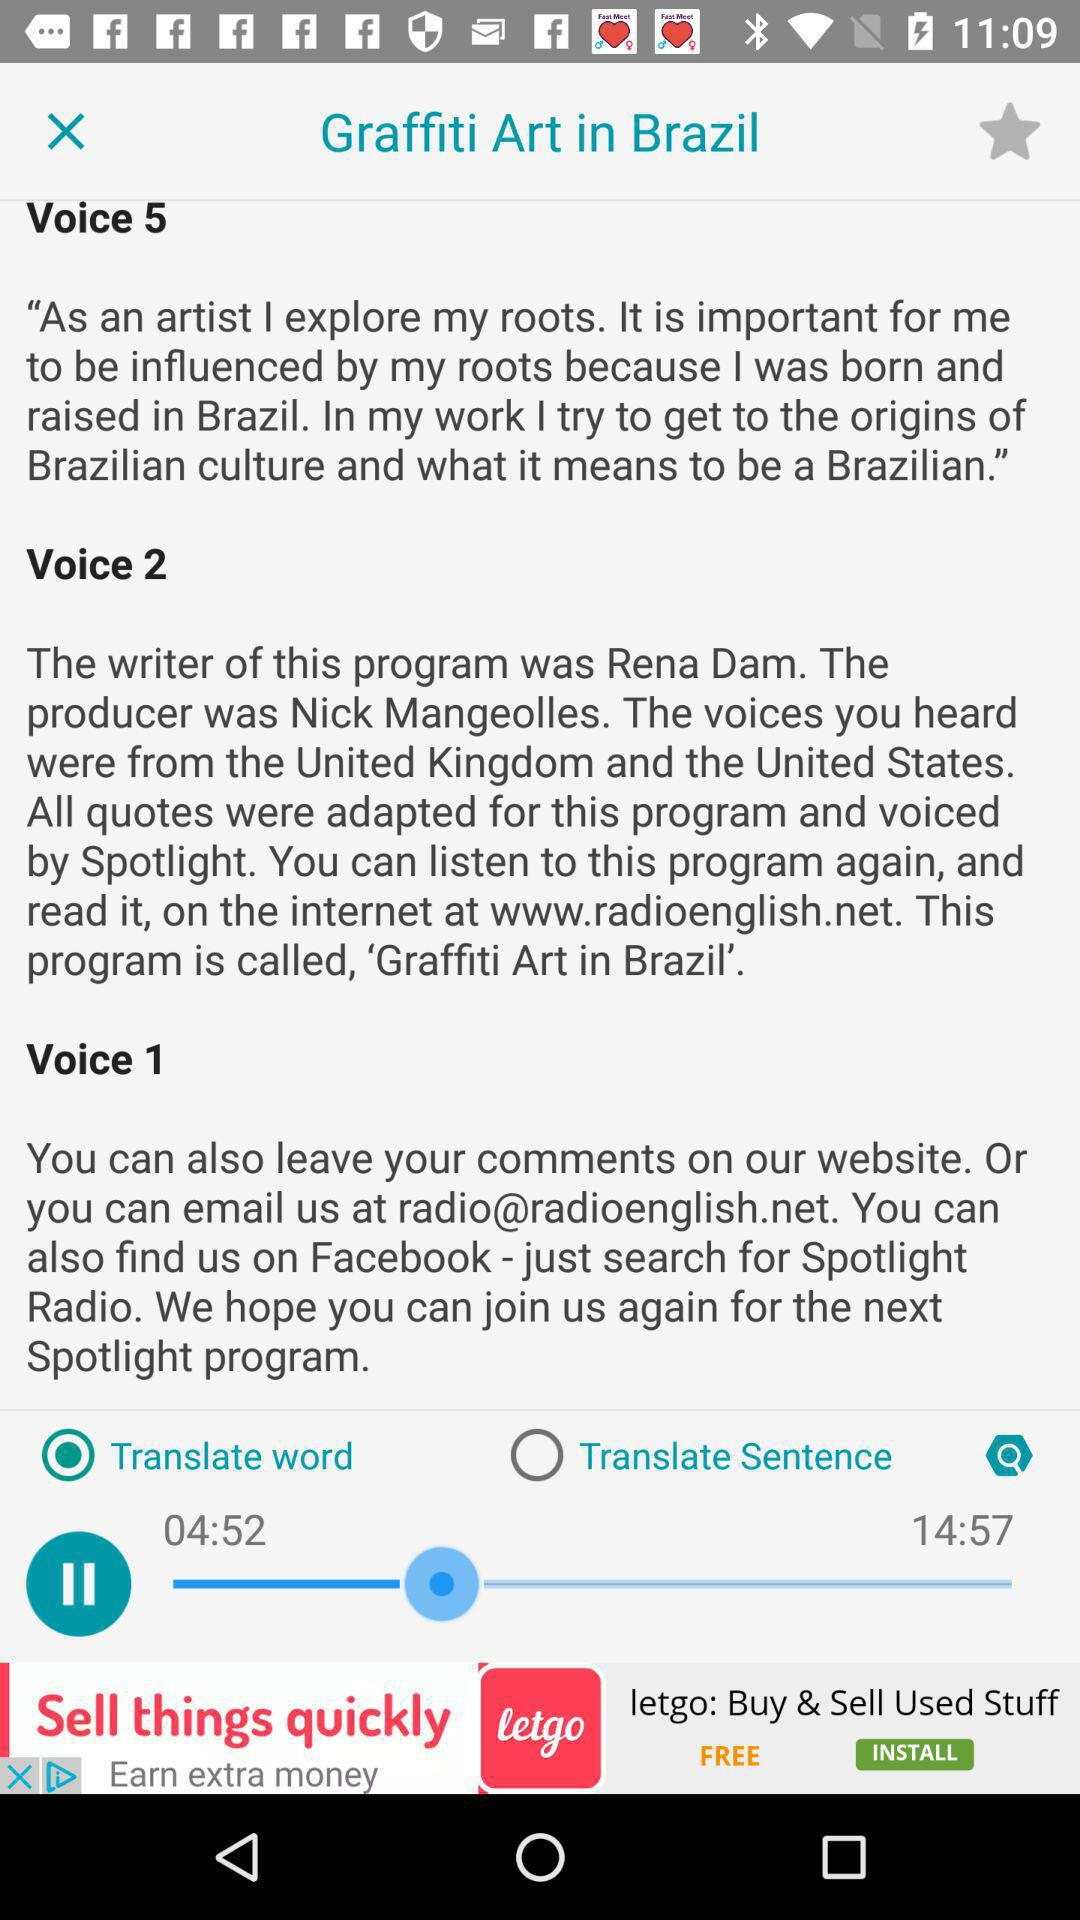What's the email address? The email address is "radio@radioenglish.net". 